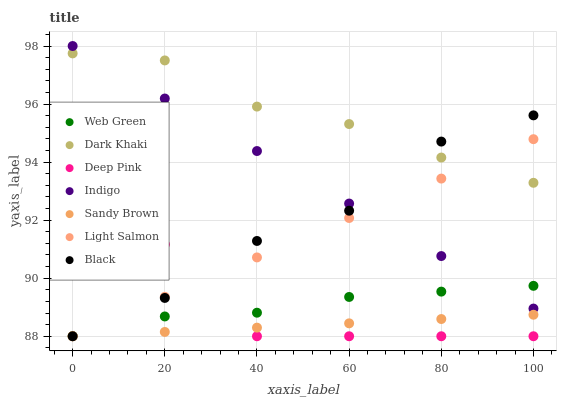Does Sandy Brown have the minimum area under the curve?
Answer yes or no. Yes. Does Dark Khaki have the maximum area under the curve?
Answer yes or no. Yes. Does Deep Pink have the minimum area under the curve?
Answer yes or no. No. Does Deep Pink have the maximum area under the curve?
Answer yes or no. No. Is Light Salmon the smoothest?
Answer yes or no. Yes. Is Deep Pink the roughest?
Answer yes or no. Yes. Is Indigo the smoothest?
Answer yes or no. No. Is Indigo the roughest?
Answer yes or no. No. Does Light Salmon have the lowest value?
Answer yes or no. Yes. Does Indigo have the lowest value?
Answer yes or no. No. Does Indigo have the highest value?
Answer yes or no. Yes. Does Deep Pink have the highest value?
Answer yes or no. No. Is Deep Pink less than Indigo?
Answer yes or no. Yes. Is Indigo greater than Sandy Brown?
Answer yes or no. Yes. Does Deep Pink intersect Black?
Answer yes or no. Yes. Is Deep Pink less than Black?
Answer yes or no. No. Is Deep Pink greater than Black?
Answer yes or no. No. Does Deep Pink intersect Indigo?
Answer yes or no. No. 